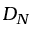Convert formula to latex. <formula><loc_0><loc_0><loc_500><loc_500>D _ { N }</formula> 